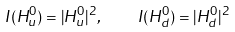<formula> <loc_0><loc_0><loc_500><loc_500>I ( H ^ { 0 } _ { u } ) = | H ^ { 0 } _ { u } | ^ { 2 } , \quad I ( H ^ { 0 } _ { d } ) = | H ^ { 0 } _ { d } | ^ { 2 }</formula> 